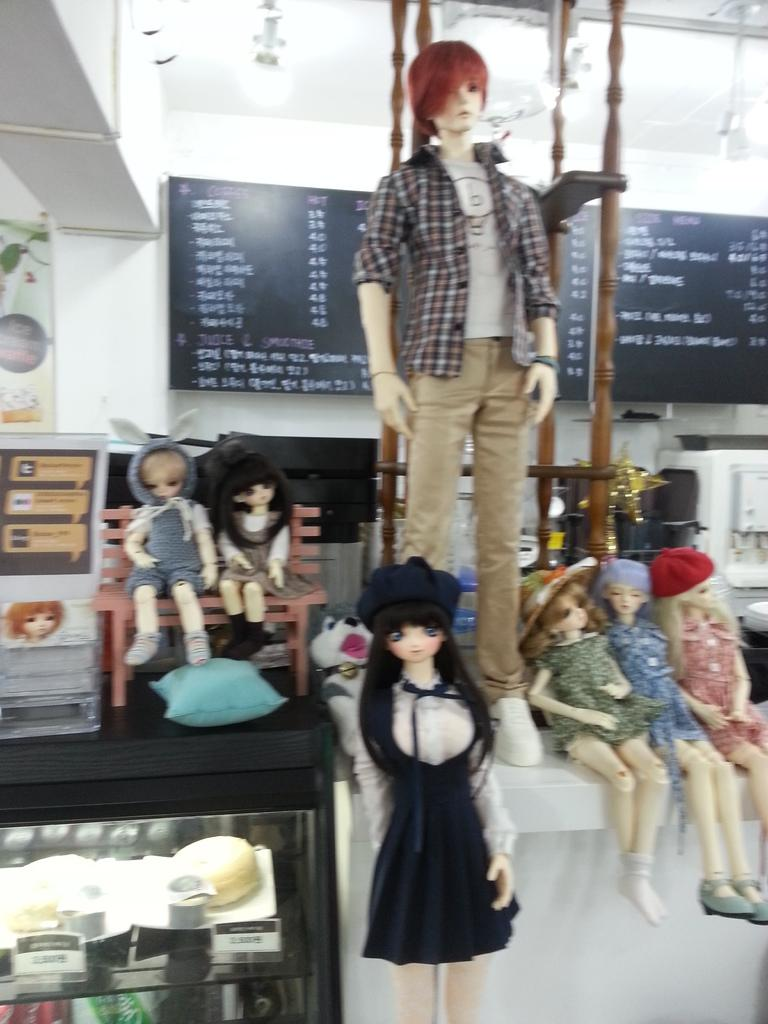What objects can be seen at the bottom of the image? There are tables at the bottom of the image. What is placed on the tables? Dolls are placed on the tables. What can be seen on the wall in the background of the image? There is a board on the wall in the background of the image. What type of steel beam can be seen supporting the tables in the image? There is no steel beam visible in the image; the tables are supported by the floor or another unseen surface. 